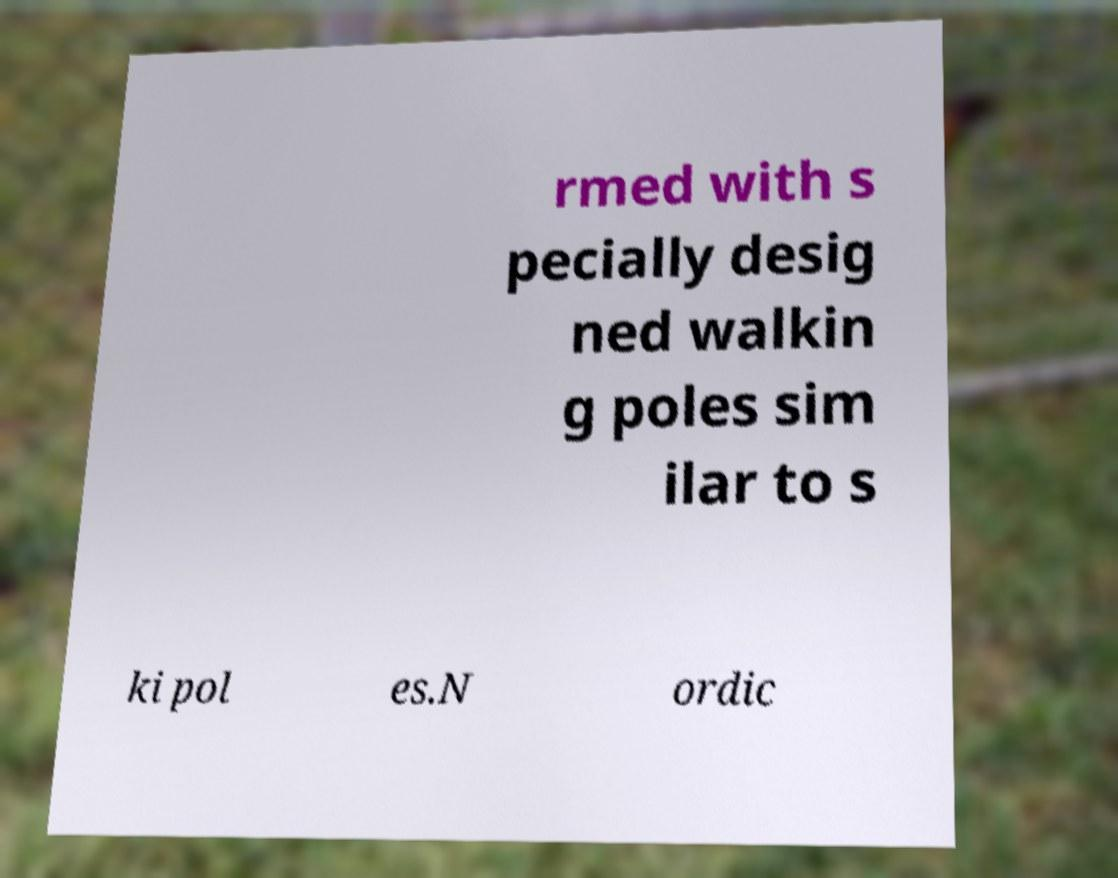Could you extract and type out the text from this image? rmed with s pecially desig ned walkin g poles sim ilar to s ki pol es.N ordic 